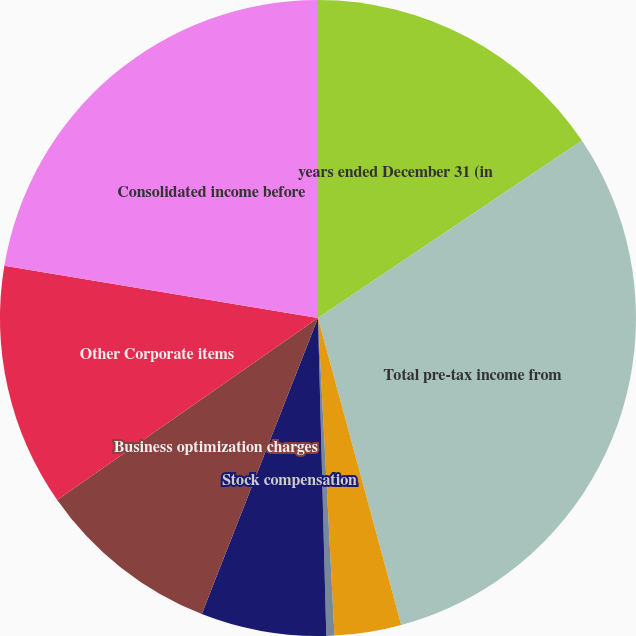Convert chart. <chart><loc_0><loc_0><loc_500><loc_500><pie_chart><fcel>years ended December 31 (in<fcel>Total pre-tax income from<fcel>Net interest expense<fcel>Certain foreign exchange<fcel>Stock compensation<fcel>Business optimization charges<fcel>Other Corporate items<fcel>Consolidated income before<nl><fcel>15.58%<fcel>30.21%<fcel>3.39%<fcel>0.41%<fcel>6.37%<fcel>9.35%<fcel>12.33%<fcel>22.37%<nl></chart> 